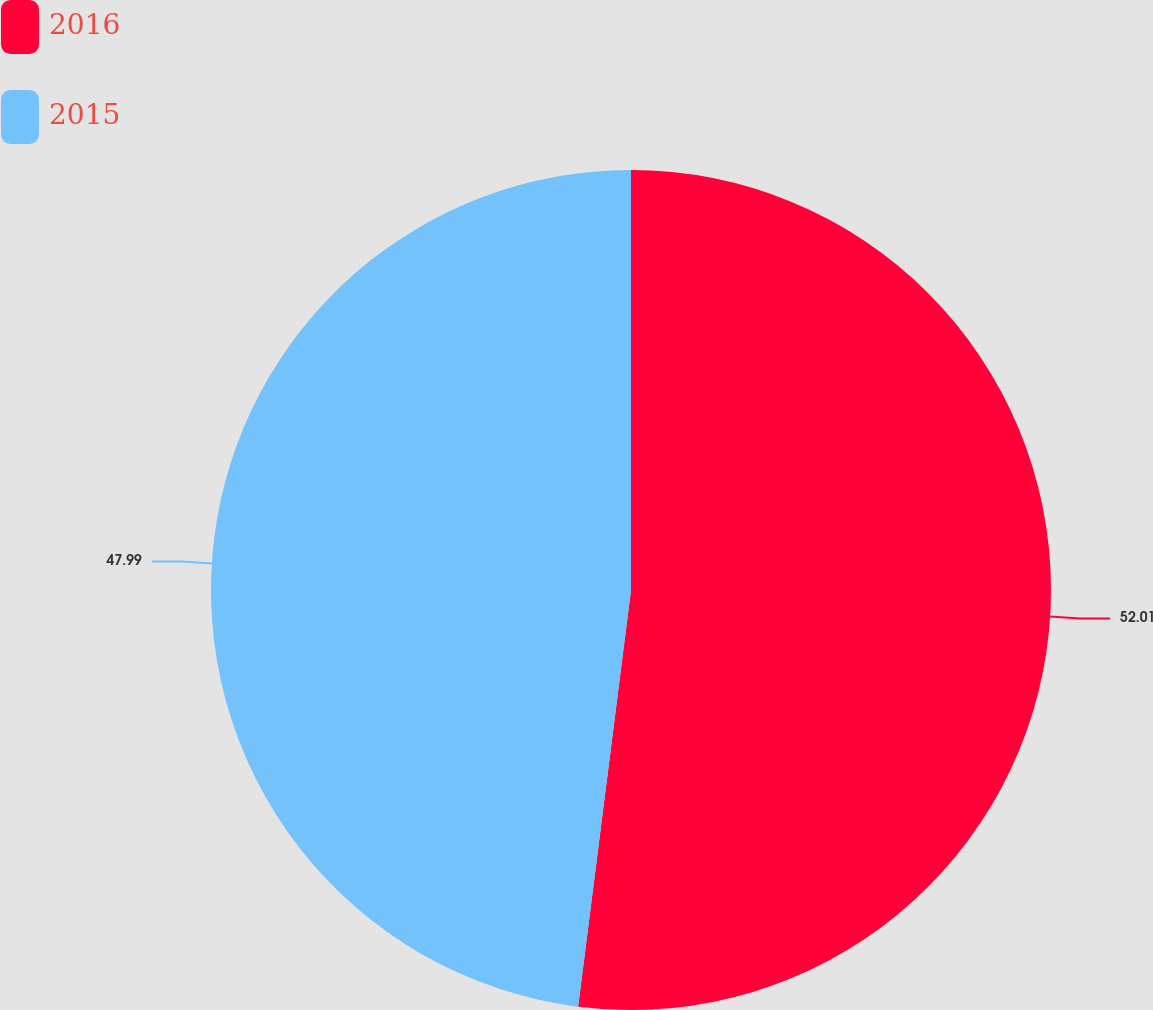Convert chart to OTSL. <chart><loc_0><loc_0><loc_500><loc_500><pie_chart><fcel>2016<fcel>2015<nl><fcel>52.01%<fcel>47.99%<nl></chart> 